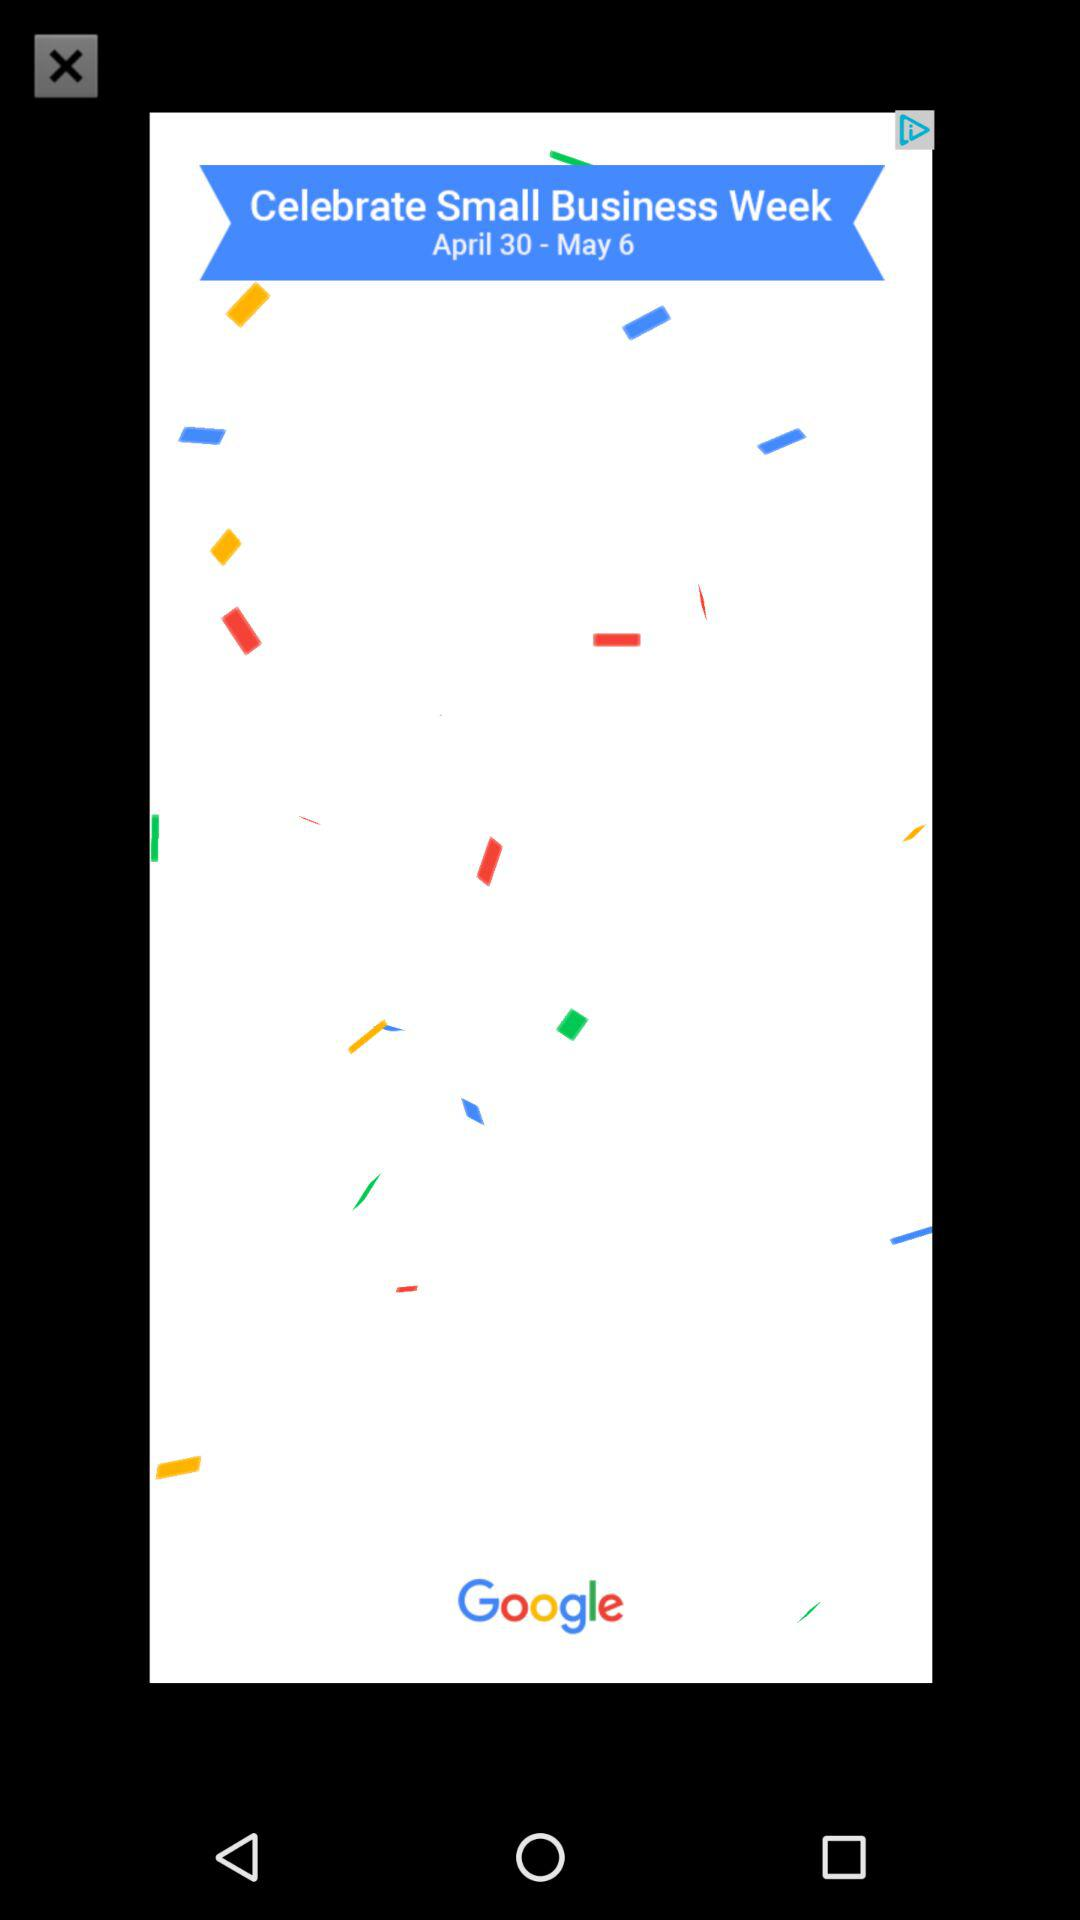What is the date range for "Celebrate Small Business Week"? The date range for "Celebrate Small Business Week" is from April 30 to May 6. 